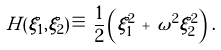<formula> <loc_0><loc_0><loc_500><loc_500>H ( \xi _ { 1 } , \xi _ { 2 } ) \, \equiv \, \frac { 1 } { 2 } \left ( \xi _ { 1 } ^ { 2 } \, + \, \omega ^ { 2 } \xi _ { 2 } ^ { 2 } \right ) \, .</formula> 